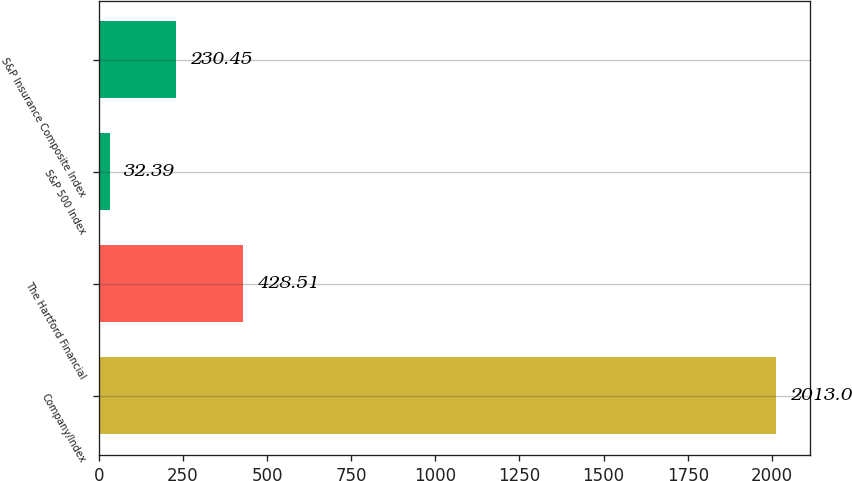<chart> <loc_0><loc_0><loc_500><loc_500><bar_chart><fcel>Company/Index<fcel>The Hartford Financial<fcel>S&P 500 Index<fcel>S&P Insurance Composite Index<nl><fcel>2013<fcel>428.51<fcel>32.39<fcel>230.45<nl></chart> 